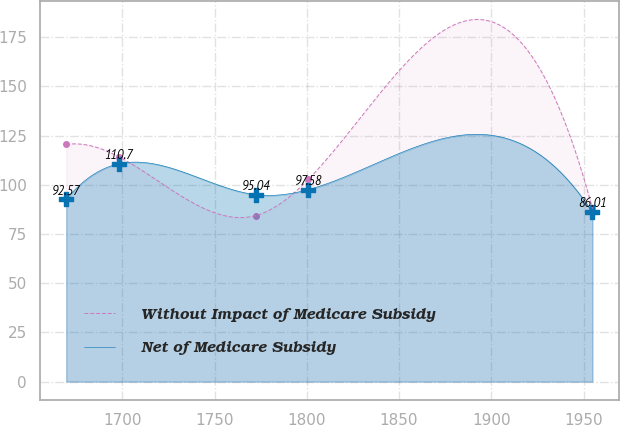Convert chart. <chart><loc_0><loc_0><loc_500><loc_500><line_chart><ecel><fcel>Without Impact of Medicare Subsidy<fcel>Net of Medicare Subsidy<nl><fcel>1669.62<fcel>120.53<fcel>92.57<nl><fcel>1698.14<fcel>114.3<fcel>110.7<nl><fcel>1772.27<fcel>84.39<fcel>95.04<nl><fcel>1800.79<fcel>102.74<fcel>97.58<nl><fcel>1954.83<fcel>88<fcel>86.01<nl></chart> 